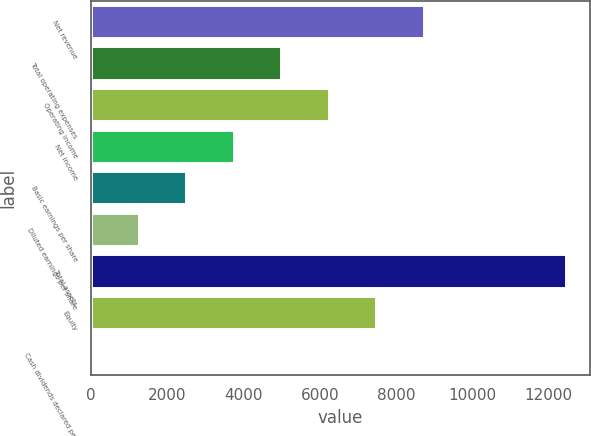Convert chart to OTSL. <chart><loc_0><loc_0><loc_500><loc_500><bar_chart><fcel>Net revenue<fcel>Total operating expenses<fcel>Operating income<fcel>Net income<fcel>Basic earnings per share<fcel>Diluted earnings per share<fcel>Total assets<fcel>Equity<fcel>Cash dividends declared per<nl><fcel>8723.45<fcel>4984.88<fcel>6231.07<fcel>3738.69<fcel>2492.5<fcel>1246.31<fcel>12462<fcel>7477.26<fcel>0.12<nl></chart> 